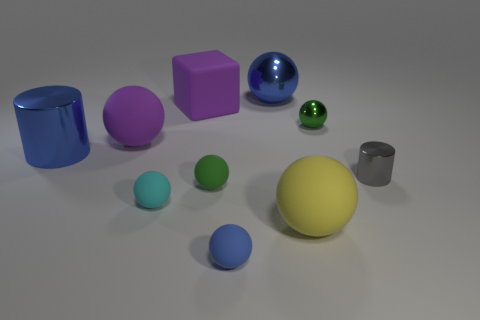Does the rubber sphere that is behind the small metal cylinder have the same color as the large cube?
Provide a succinct answer. Yes. What is the shape of the tiny green object behind the small metal object that is in front of the big metallic cylinder?
Your response must be concise. Sphere. Are there any other things that have the same shape as the gray thing?
Your answer should be very brief. Yes. There is another metal object that is the same shape as the tiny green metal thing; what is its color?
Your answer should be very brief. Blue. Does the tiny cylinder have the same color as the metal cylinder to the left of the big yellow matte object?
Your response must be concise. No. What is the shape of the small thing that is to the right of the cyan ball and in front of the green matte sphere?
Your response must be concise. Sphere. Is the number of gray rubber objects less than the number of tiny cyan objects?
Offer a terse response. Yes. Are any small blue rubber spheres visible?
Your response must be concise. Yes. How many other things are the same size as the blue cylinder?
Provide a short and direct response. 4. Are the cyan object and the blue ball that is behind the tiny gray metal object made of the same material?
Provide a short and direct response. No. 